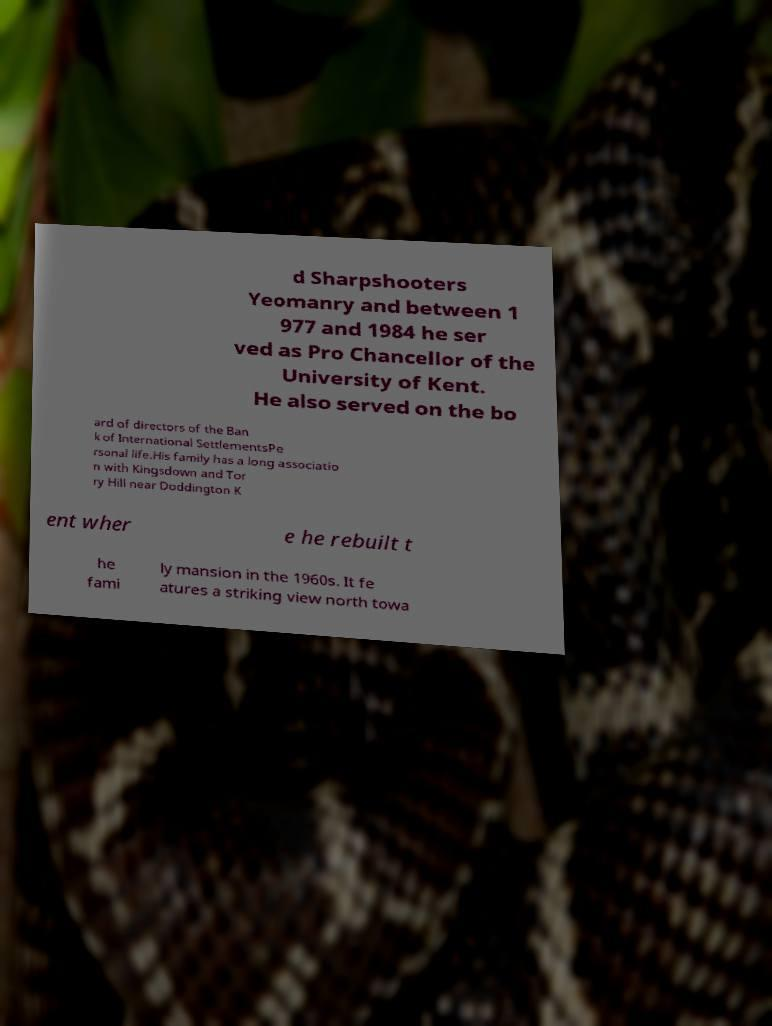Please read and relay the text visible in this image. What does it say? d Sharpshooters Yeomanry and between 1 977 and 1984 he ser ved as Pro Chancellor of the University of Kent. He also served on the bo ard of directors of the Ban k of International SettlementsPe rsonal life.His family has a long associatio n with Kingsdown and Tor ry Hill near Doddington K ent wher e he rebuilt t he fami ly mansion in the 1960s. It fe atures a striking view north towa 